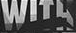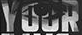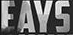What words are shown in these images in order, separated by a semicolon? WITH; YOUR; EAYS 